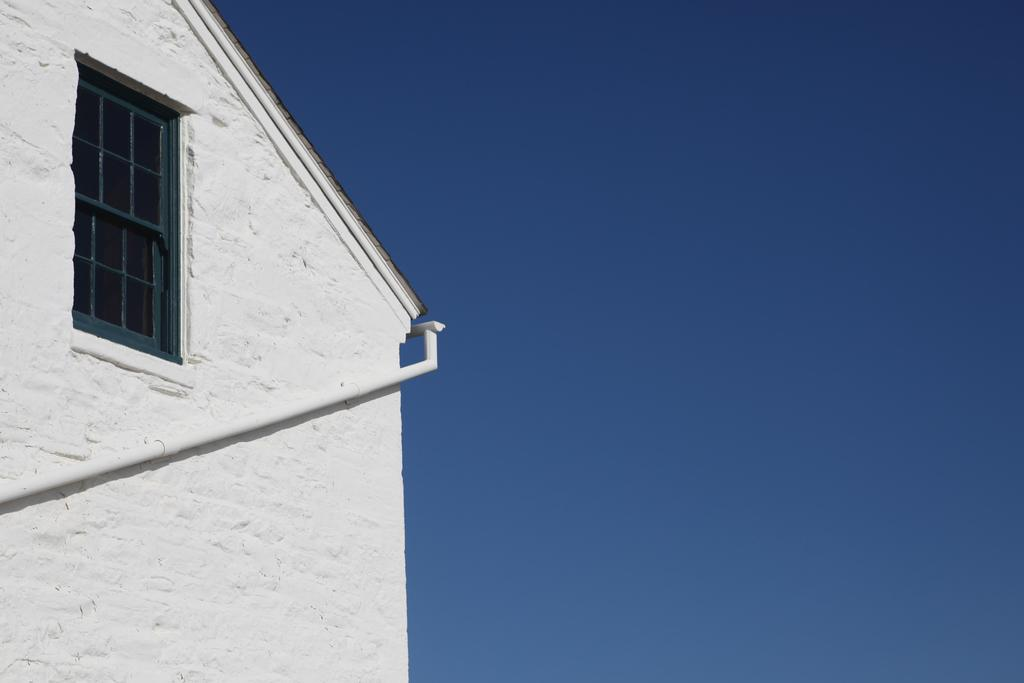What type of structure is located on the left side of the image? There is a white-colored building on the left side of the image. What can be seen on the building in the image? There is a white-colored pipe on the building. Can you describe any openings in the building? Yes, there is a window visible in the image. What is visible on the right side of the image? The sky is visible on the right side of the image. What type of light is emitted from the doctor in the image? There is no doctor present in the image, so it is not possible to determine what type of light might be emitted from one. 